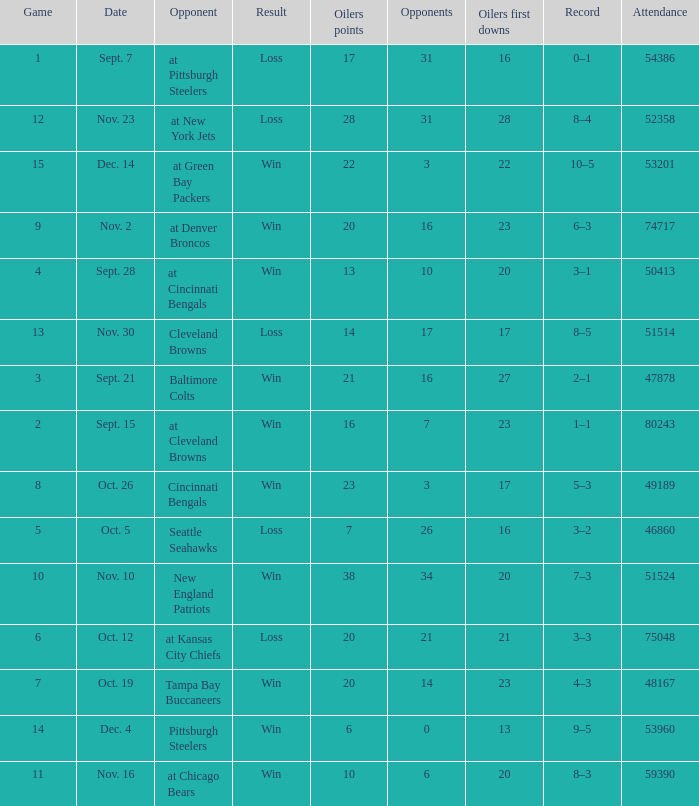What was the total opponents points for the game were the Oilers scored 21? 16.0. 